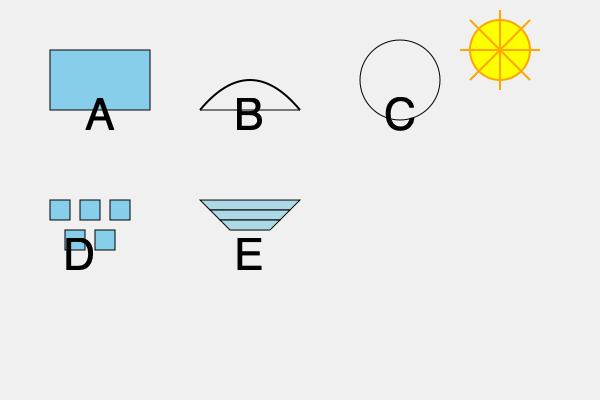Given the extreme distance from the Sun and the harsh conditions on Pluto, which of the illustrated solar energy collection designs (A-E) would be most efficient for powering a future human settlement, considering the need to maximize energy capture from the dim sunlight? To determine the most efficient solar energy collection system for a human settlement on Pluto, we need to consider several factors:

1. Distance from the Sun: Pluto is approximately 40 AU (Astronomical Units) from the Sun, receiving only about 1/1600th of the sunlight that reaches Earth.

2. Low light intensity: Due to the extreme distance, the sunlight reaching Pluto is very weak, requiring a system that can concentrate light effectively.

3. Harsh conditions: Pluto's surface temperature is around -230°C (-382°F), which can affect the efficiency and durability of solar panels.

4. Need for precision: With such weak sunlight, the collection system must be highly accurate in tracking and focusing the available light.

Analyzing the designs:

A. Flat Panel: While simple, it would be inefficient on Pluto due to the extremely low light intensity.

B. Parabolic Dish: This design can concentrate sunlight effectively, which is crucial for the low-light conditions on Pluto.

C. Spherical Collector: Similar to the parabolic dish but less efficient in focusing light to a single point.

D. Heliostat Array: Multiple small mirrors that can be adjusted to reflect light to a central collector. This design offers flexibility and can be scaled up easily.

E. Fresnel Lens: This design can concentrate light effectively and is lighter than a traditional lens, which could be advantageous for transportation to Pluto.

Considering these factors, the most efficient design for Pluto would be the Heliostat Array (D). This system offers several advantages:

1. Scalability: The array can be expanded to cover a large area, maximizing light collection.
2. Precision: Each mirror can be individually adjusted to track the Sun's position accurately.
3. Concentration: The collected light can be focused on a central point, significantly increasing energy density.
4. Redundancy: If some mirrors fail, the system can still function, unlike a single large collector.
5. Adaptability: The array can be reconfigured or partially redeployed as needed.

The Heliostat Array would provide the best combination of light concentration, adaptability, and resilience needed for the extreme conditions and low light intensity on Pluto.
Answer: Heliostat Array (D) 